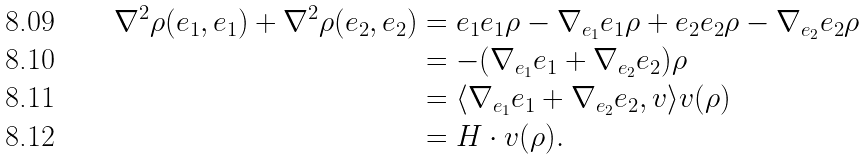Convert formula to latex. <formula><loc_0><loc_0><loc_500><loc_500>\nabla ^ { 2 } \rho ( e _ { 1 } , e _ { 1 } ) + \nabla ^ { 2 } \rho ( e _ { 2 } , e _ { 2 } ) & = e _ { 1 } e _ { 1 } \rho - \nabla _ { e _ { 1 } } e _ { 1 } \rho + e _ { 2 } e _ { 2 } \rho - \nabla _ { e _ { 2 } } e _ { 2 } \rho \\ & = - ( \nabla _ { e _ { 1 } } e _ { 1 } + \nabla _ { e _ { 2 } } e _ { 2 } ) \rho \\ & = \langle \nabla _ { e _ { 1 } } e _ { 1 } + \nabla _ { e _ { 2 } } e _ { 2 } , v \rangle v ( \rho ) \\ & = H \cdot v ( \rho ) .</formula> 